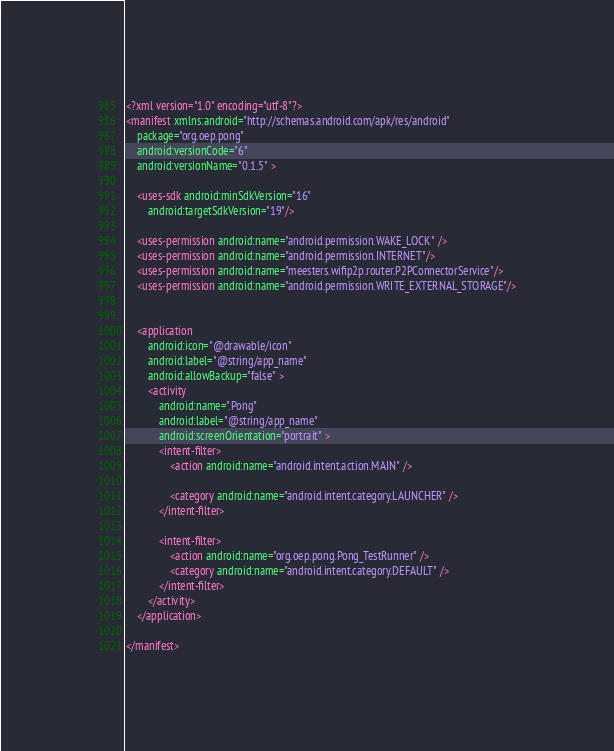<code> <loc_0><loc_0><loc_500><loc_500><_XML_><?xml version="1.0" encoding="utf-8"?>
<manifest xmlns:android="http://schemas.android.com/apk/res/android"
    package="org.oep.pong"
    android:versionCode="6"
    android:versionName="0.1.5" >

    <uses-sdk android:minSdkVersion="16" 
        android:targetSdkVersion="19"/>

    <uses-permission android:name="android.permission.WAKE_LOCK" />
    <uses-permission android:name="android.permission.INTERNET"/>
    <uses-permission android:name="meesters.wifip2p.router.P2PConnectorService"/>
    <uses-permission android:name="android.permission.WRITE_EXTERNAL_STORAGE"/>
    

    <application
        android:icon="@drawable/icon"
        android:label="@string/app_name"
        android:allowBackup="false" >
        <activity
            android:name=".Pong"
            android:label="@string/app_name"
            android:screenOrientation="portrait" >
            <intent-filter>
                <action android:name="android.intent.action.MAIN" />

                <category android:name="android.intent.category.LAUNCHER" />
            </intent-filter>
            
            <intent-filter>
                <action android:name="org.oep.pong.Pong_TestRunner" />
                <category android:name="android.intent.category.DEFAULT" />
            </intent-filter>
        </activity>
    </application>

</manifest></code> 